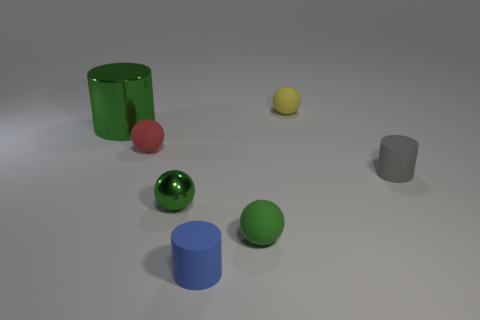Add 2 matte cylinders. How many objects exist? 9 Subtract all cylinders. How many objects are left? 4 Subtract all small red rubber objects. Subtract all rubber cylinders. How many objects are left? 4 Add 4 small green metallic balls. How many small green metallic balls are left? 5 Add 1 small green objects. How many small green objects exist? 3 Subtract 0 blue cubes. How many objects are left? 7 